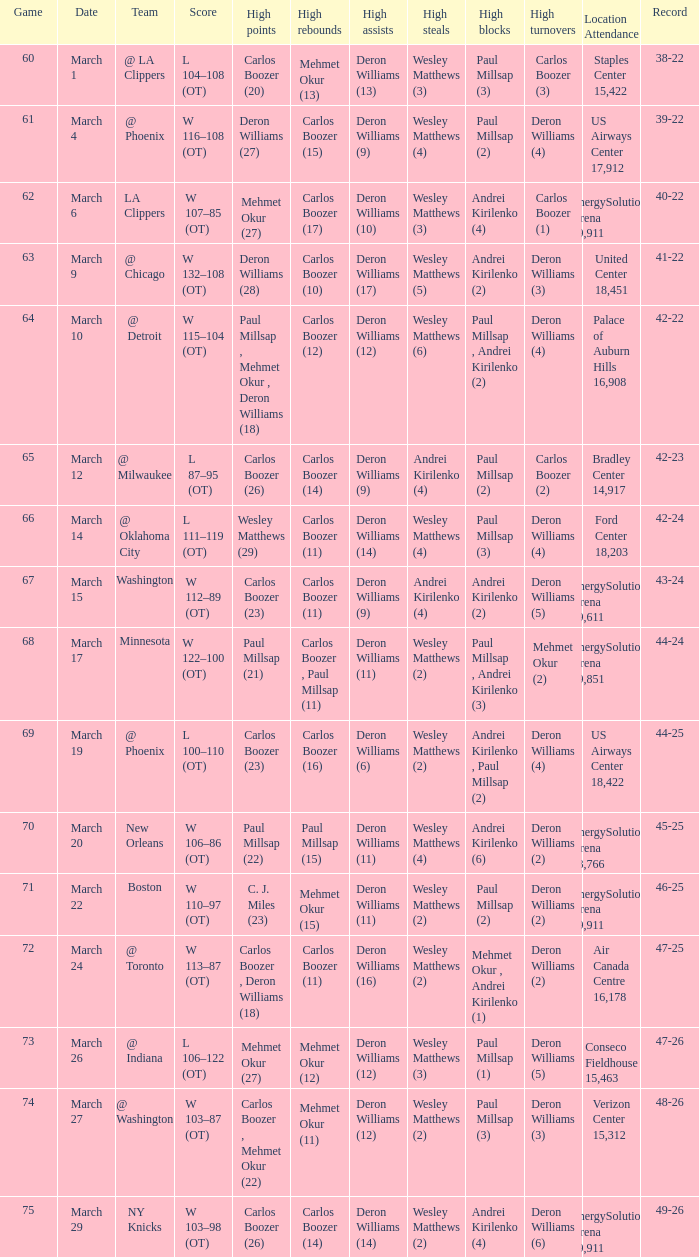What was the record at the game where Deron Williams (6) did the high assists? 44-25. 